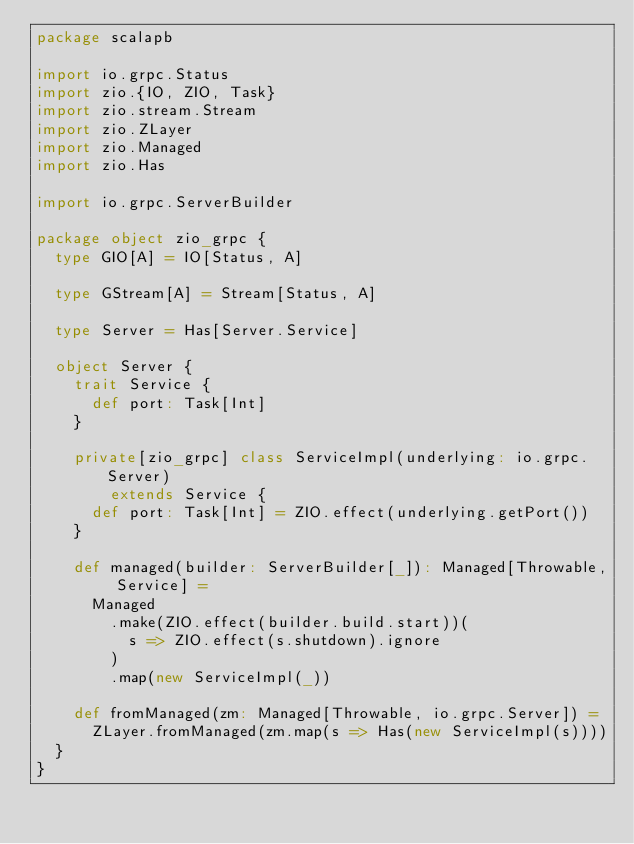Convert code to text. <code><loc_0><loc_0><loc_500><loc_500><_Scala_>package scalapb

import io.grpc.Status
import zio.{IO, ZIO, Task}
import zio.stream.Stream
import zio.ZLayer
import zio.Managed
import zio.Has

import io.grpc.ServerBuilder

package object zio_grpc {
  type GIO[A] = IO[Status, A]

  type GStream[A] = Stream[Status, A]

  type Server = Has[Server.Service]

  object Server {
    trait Service {
      def port: Task[Int]
    }

    private[zio_grpc] class ServiceImpl(underlying: io.grpc.Server)
        extends Service {
      def port: Task[Int] = ZIO.effect(underlying.getPort())
    }

    def managed(builder: ServerBuilder[_]): Managed[Throwable, Service] =
      Managed
        .make(ZIO.effect(builder.build.start))(
          s => ZIO.effect(s.shutdown).ignore
        )
        .map(new ServiceImpl(_))

    def fromManaged(zm: Managed[Throwable, io.grpc.Server]) =
      ZLayer.fromManaged(zm.map(s => Has(new ServiceImpl(s))))
  }
}
</code> 